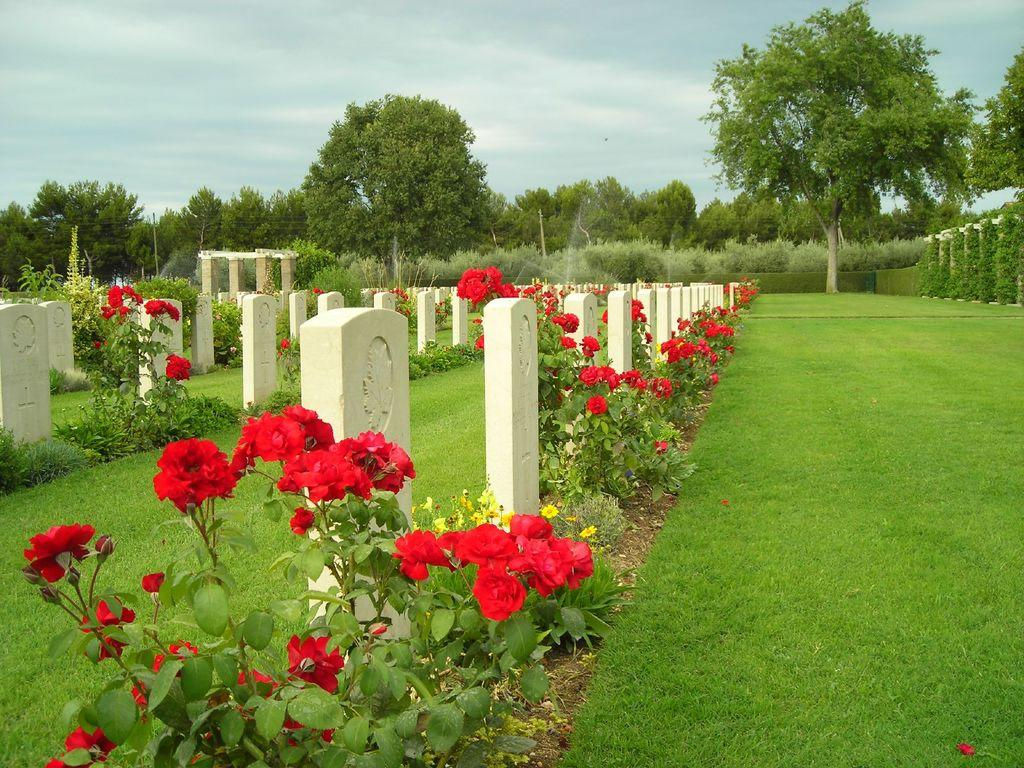What type of vegetation is on the ground in the image? There is grass on the ground in the image. What specific type of flowering plants can be seen in the image? There are rose plants in the image. Are there any other types of plants visible besides the roses? Yes, there are other plants in the image. What structures are near the plants in the image? There are poles near the plants in the image. What can be seen in the background of the image? There are trees and the sky visible in the background of the image. What type of bun is being used to twist the plants in the image? There is no bun or twisting of plants present in the image. 